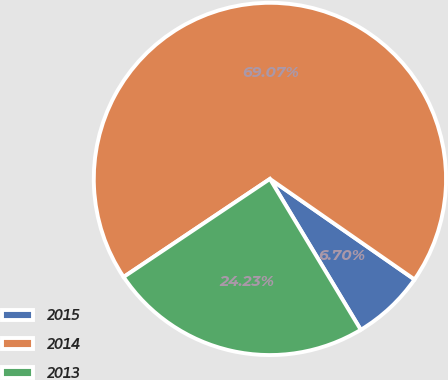Convert chart to OTSL. <chart><loc_0><loc_0><loc_500><loc_500><pie_chart><fcel>2015<fcel>2014<fcel>2013<nl><fcel>6.7%<fcel>69.07%<fcel>24.23%<nl></chart> 